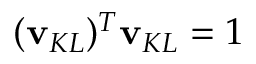<formula> <loc_0><loc_0><loc_500><loc_500>( v _ { K L } ) ^ { T } v _ { K L } = 1</formula> 